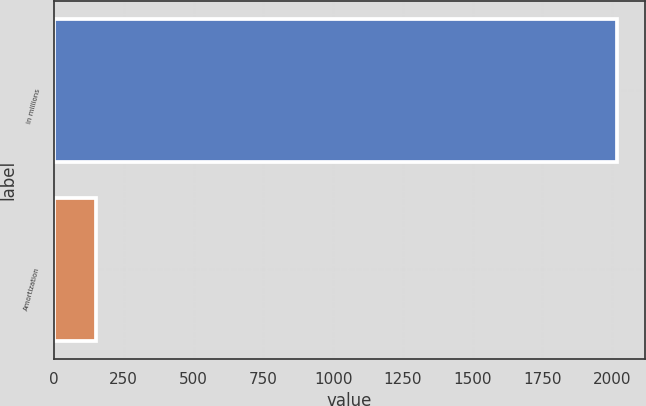<chart> <loc_0><loc_0><loc_500><loc_500><bar_chart><fcel>in millions<fcel>Amortization<nl><fcel>2018<fcel>152<nl></chart> 